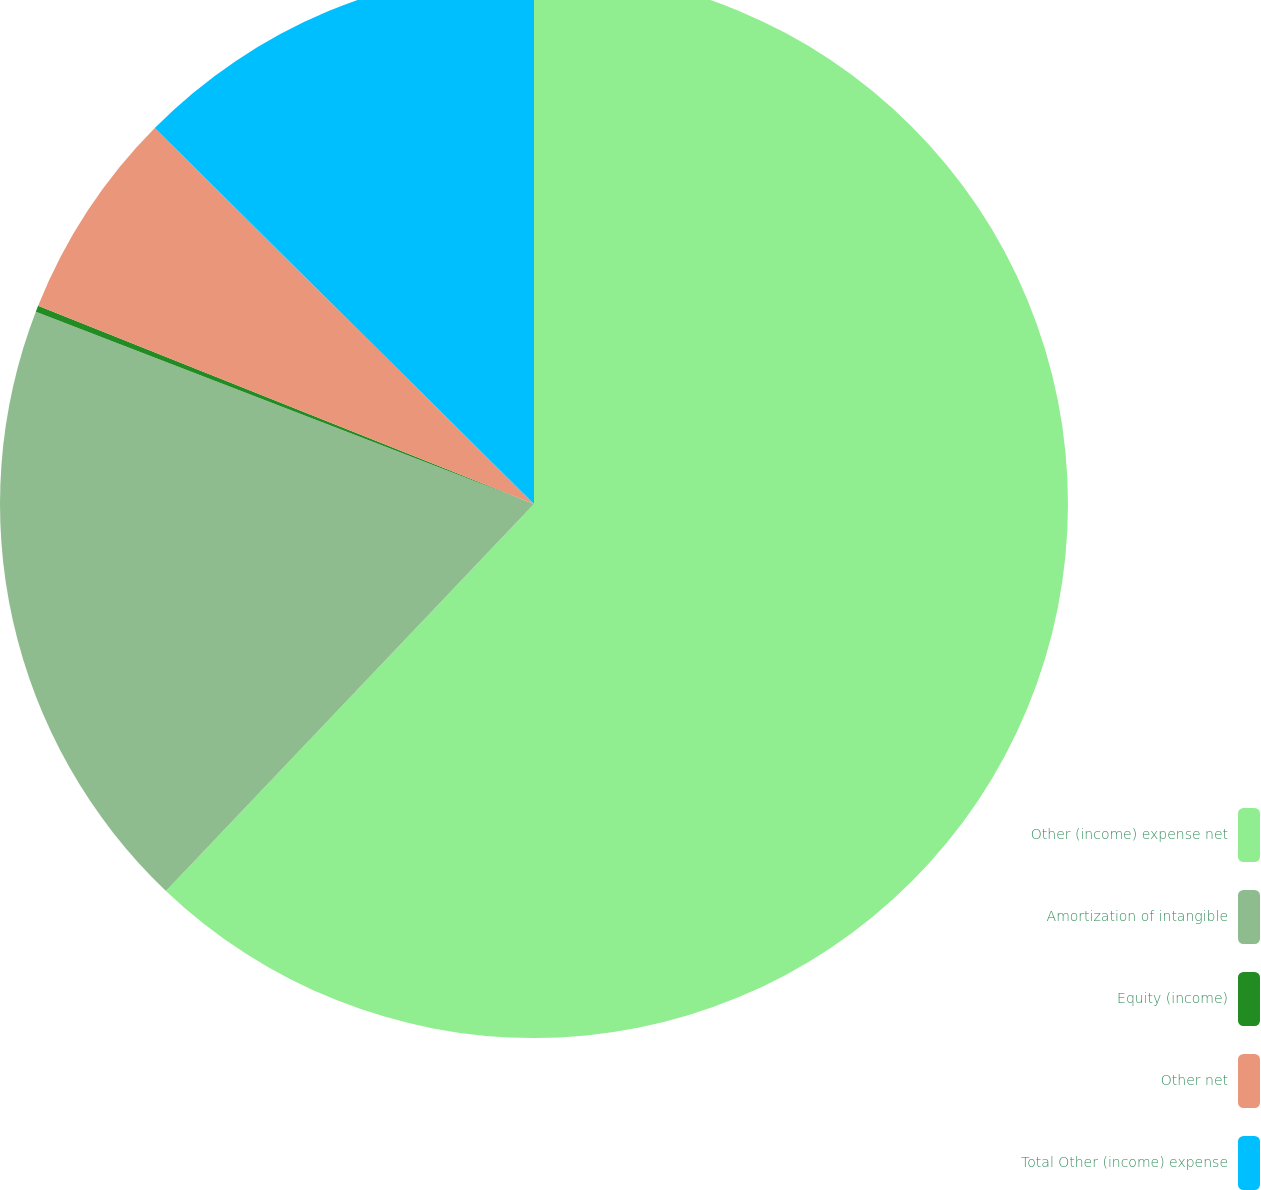Convert chart. <chart><loc_0><loc_0><loc_500><loc_500><pie_chart><fcel>Other (income) expense net<fcel>Amortization of intangible<fcel>Equity (income)<fcel>Other net<fcel>Total Other (income) expense<nl><fcel>62.11%<fcel>18.76%<fcel>0.19%<fcel>6.38%<fcel>12.57%<nl></chart> 